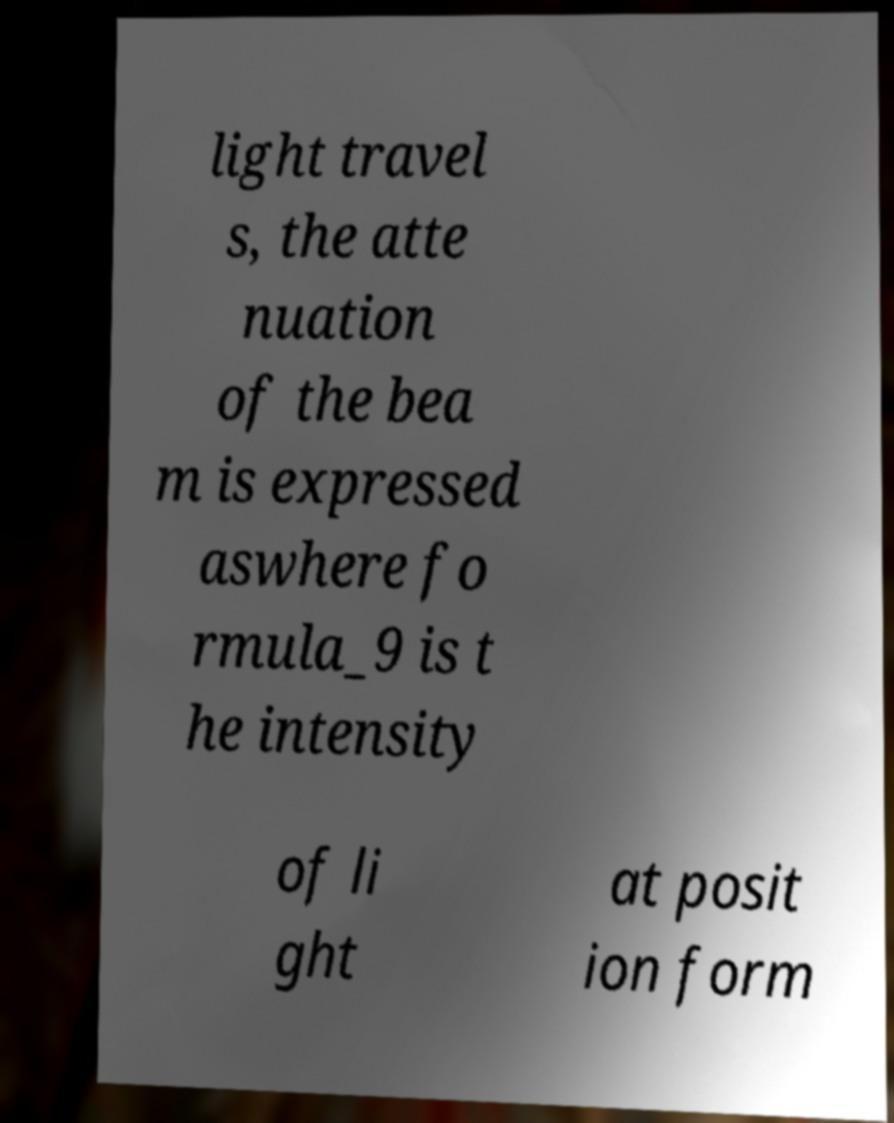I need the written content from this picture converted into text. Can you do that? light travel s, the atte nuation of the bea m is expressed aswhere fo rmula_9 is t he intensity of li ght at posit ion form 